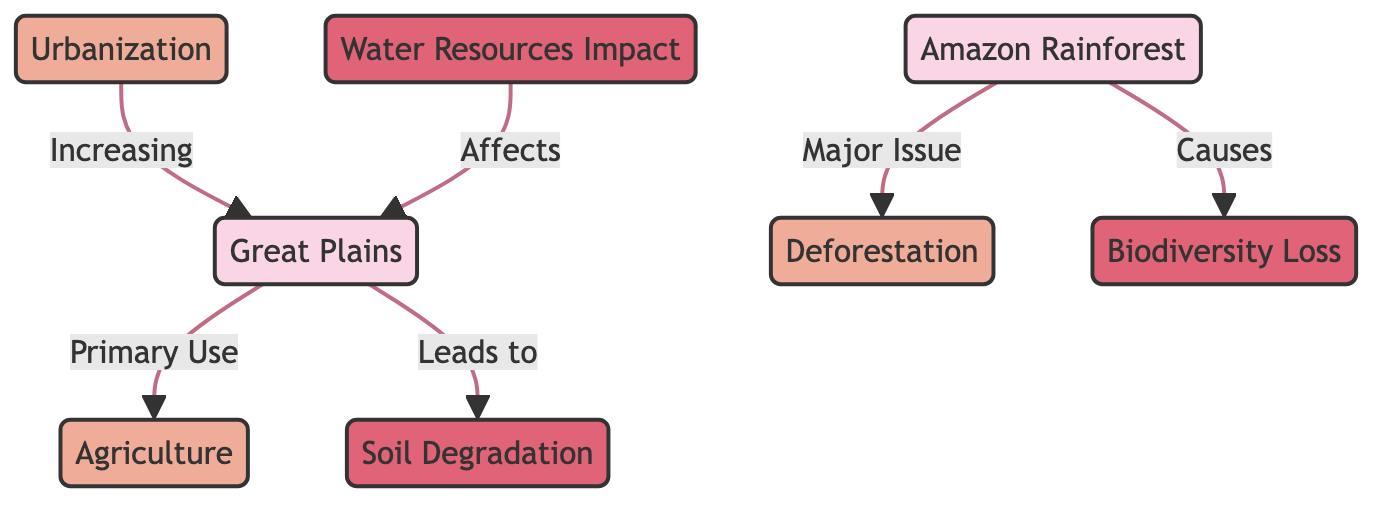What is the major issue in the Amazon Rainforest? The diagram identifies deforestation as the major issue affecting the Amazon Rainforest region, linking it directly to the region.
Answer: Deforestation What impact does deforestation lead to? In the diagram, deforestation is shown as causing biodiversity loss, indicating a direct relationship from the land use pattern to its environmental impact.
Answer: Biodiversity Loss Which land use is primary in the Great Plains? The diagram states that agriculture is the primary use of land in the Great Plains region, establishing its significance in that area.
Answer: Agriculture How many total impacts are associated with the Great Plains region? Two impacts, soil degradation and water resources impact, are listed in the diagram that affect the Great Plains, indicating direct consequences of land use practices.
Answer: 2 What leads to soil degradation in the Great Plains? The flowchart states that agriculture leads to soil degradation, establishing a causal link between the land use type and its negative impact.
Answer: Agriculture Which region experiences increasing urbanization? The diagram shows that urbanization is increasing in the Great Plains region, representing a trend within the land use patterns of that area.
Answer: Great Plains What is affected by water resources impact? The diagram illustrates that water resources impact is a consequence affecting the Great Plains, linking it to the overall land use practices there.
Answer: Great Plains What is the relationship between deforestation and biodiversity loss? The diagram depicts a direct causal relationship where deforestation is indicated to cause biodiversity loss in the Amazon Rainforest region.
Answer: Causes Which edge connects biodiversity loss to the Amazon Rainforest? An edge is drawn from the Amazon Rainforest region to biodiversity loss, specifically indicating it is a consequence of deforestation in that area.
Answer: Major Issue 